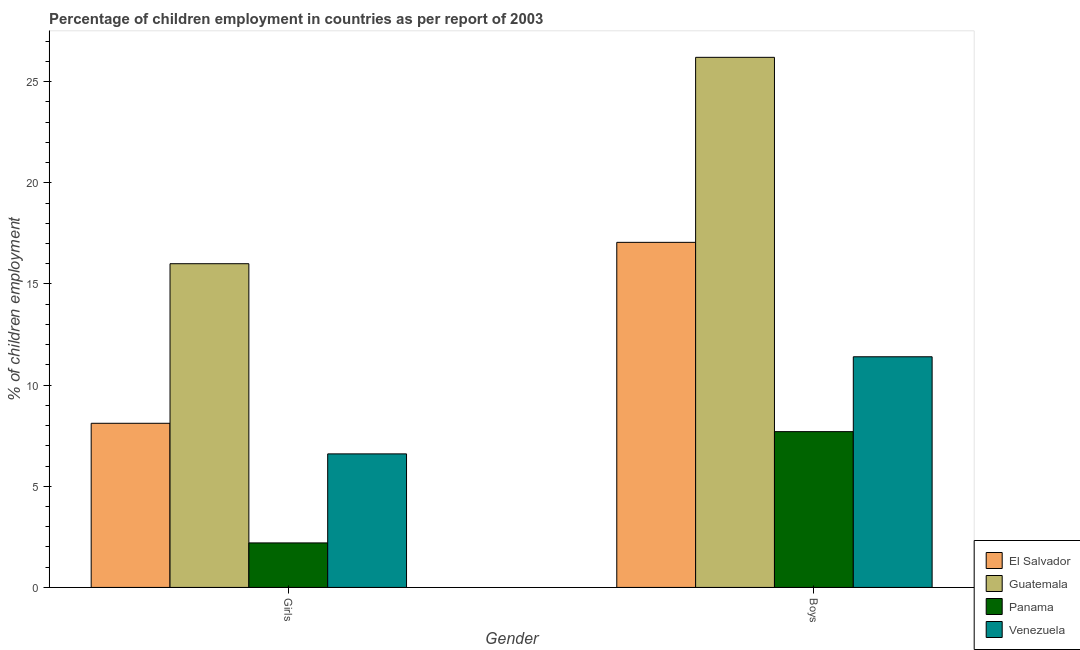How many bars are there on the 1st tick from the left?
Offer a terse response. 4. How many bars are there on the 2nd tick from the right?
Keep it short and to the point. 4. What is the label of the 1st group of bars from the left?
Keep it short and to the point. Girls. What is the percentage of employed boys in El Salvador?
Give a very brief answer. 17.06. Across all countries, what is the maximum percentage of employed girls?
Offer a terse response. 16. Across all countries, what is the minimum percentage of employed girls?
Make the answer very short. 2.2. In which country was the percentage of employed boys maximum?
Give a very brief answer. Guatemala. In which country was the percentage of employed boys minimum?
Provide a short and direct response. Panama. What is the total percentage of employed boys in the graph?
Your answer should be compact. 62.36. What is the difference between the percentage of employed boys in El Salvador and that in Venezuela?
Provide a short and direct response. 5.66. What is the difference between the percentage of employed boys in Venezuela and the percentage of employed girls in Guatemala?
Ensure brevity in your answer.  -4.6. What is the average percentage of employed boys per country?
Offer a terse response. 15.59. What is the difference between the percentage of employed boys and percentage of employed girls in Venezuela?
Give a very brief answer. 4.8. What is the ratio of the percentage of employed girls in El Salvador to that in Panama?
Provide a short and direct response. 3.69. In how many countries, is the percentage of employed girls greater than the average percentage of employed girls taken over all countries?
Offer a terse response. 1. What does the 2nd bar from the left in Girls represents?
Make the answer very short. Guatemala. What does the 3rd bar from the right in Girls represents?
Offer a very short reply. Guatemala. Are all the bars in the graph horizontal?
Offer a very short reply. No. How many countries are there in the graph?
Provide a short and direct response. 4. Does the graph contain any zero values?
Provide a succinct answer. No. What is the title of the graph?
Ensure brevity in your answer.  Percentage of children employment in countries as per report of 2003. Does "Turkmenistan" appear as one of the legend labels in the graph?
Give a very brief answer. No. What is the label or title of the X-axis?
Offer a terse response. Gender. What is the label or title of the Y-axis?
Make the answer very short. % of children employment. What is the % of children employment in El Salvador in Girls?
Your answer should be compact. 8.11. What is the % of children employment of Panama in Girls?
Keep it short and to the point. 2.2. What is the % of children employment in El Salvador in Boys?
Your response must be concise. 17.06. What is the % of children employment of Guatemala in Boys?
Provide a short and direct response. 26.2. Across all Gender, what is the maximum % of children employment of El Salvador?
Keep it short and to the point. 17.06. Across all Gender, what is the maximum % of children employment of Guatemala?
Offer a terse response. 26.2. Across all Gender, what is the maximum % of children employment of Venezuela?
Give a very brief answer. 11.4. Across all Gender, what is the minimum % of children employment in El Salvador?
Offer a very short reply. 8.11. Across all Gender, what is the minimum % of children employment in Venezuela?
Your answer should be compact. 6.6. What is the total % of children employment of El Salvador in the graph?
Make the answer very short. 25.17. What is the total % of children employment of Guatemala in the graph?
Provide a succinct answer. 42.2. What is the total % of children employment in Panama in the graph?
Offer a terse response. 9.9. What is the difference between the % of children employment in El Salvador in Girls and that in Boys?
Your response must be concise. -8.94. What is the difference between the % of children employment of Guatemala in Girls and that in Boys?
Give a very brief answer. -10.2. What is the difference between the % of children employment of Panama in Girls and that in Boys?
Ensure brevity in your answer.  -5.5. What is the difference between the % of children employment in El Salvador in Girls and the % of children employment in Guatemala in Boys?
Provide a succinct answer. -18.09. What is the difference between the % of children employment in El Salvador in Girls and the % of children employment in Panama in Boys?
Provide a succinct answer. 0.41. What is the difference between the % of children employment in El Salvador in Girls and the % of children employment in Venezuela in Boys?
Ensure brevity in your answer.  -3.29. What is the difference between the % of children employment in Guatemala in Girls and the % of children employment in Panama in Boys?
Give a very brief answer. 8.3. What is the difference between the % of children employment of Panama in Girls and the % of children employment of Venezuela in Boys?
Offer a terse response. -9.2. What is the average % of children employment in El Salvador per Gender?
Your answer should be compact. 12.58. What is the average % of children employment of Guatemala per Gender?
Give a very brief answer. 21.1. What is the average % of children employment in Panama per Gender?
Your answer should be very brief. 4.95. What is the difference between the % of children employment of El Salvador and % of children employment of Guatemala in Girls?
Keep it short and to the point. -7.89. What is the difference between the % of children employment of El Salvador and % of children employment of Panama in Girls?
Provide a short and direct response. 5.91. What is the difference between the % of children employment of El Salvador and % of children employment of Venezuela in Girls?
Your answer should be very brief. 1.51. What is the difference between the % of children employment of Guatemala and % of children employment of Panama in Girls?
Offer a terse response. 13.8. What is the difference between the % of children employment of Guatemala and % of children employment of Venezuela in Girls?
Keep it short and to the point. 9.4. What is the difference between the % of children employment in Panama and % of children employment in Venezuela in Girls?
Make the answer very short. -4.4. What is the difference between the % of children employment of El Salvador and % of children employment of Guatemala in Boys?
Your answer should be compact. -9.14. What is the difference between the % of children employment of El Salvador and % of children employment of Panama in Boys?
Keep it short and to the point. 9.36. What is the difference between the % of children employment in El Salvador and % of children employment in Venezuela in Boys?
Ensure brevity in your answer.  5.66. What is the difference between the % of children employment of Guatemala and % of children employment of Panama in Boys?
Provide a succinct answer. 18.5. What is the difference between the % of children employment in Guatemala and % of children employment in Venezuela in Boys?
Your answer should be compact. 14.8. What is the ratio of the % of children employment in El Salvador in Girls to that in Boys?
Your response must be concise. 0.48. What is the ratio of the % of children employment in Guatemala in Girls to that in Boys?
Give a very brief answer. 0.61. What is the ratio of the % of children employment of Panama in Girls to that in Boys?
Your response must be concise. 0.29. What is the ratio of the % of children employment of Venezuela in Girls to that in Boys?
Give a very brief answer. 0.58. What is the difference between the highest and the second highest % of children employment of El Salvador?
Provide a short and direct response. 8.94. What is the difference between the highest and the second highest % of children employment of Guatemala?
Offer a very short reply. 10.2. What is the difference between the highest and the second highest % of children employment of Panama?
Your answer should be very brief. 5.5. What is the difference between the highest and the lowest % of children employment in El Salvador?
Provide a succinct answer. 8.94. What is the difference between the highest and the lowest % of children employment in Guatemala?
Offer a terse response. 10.2. 